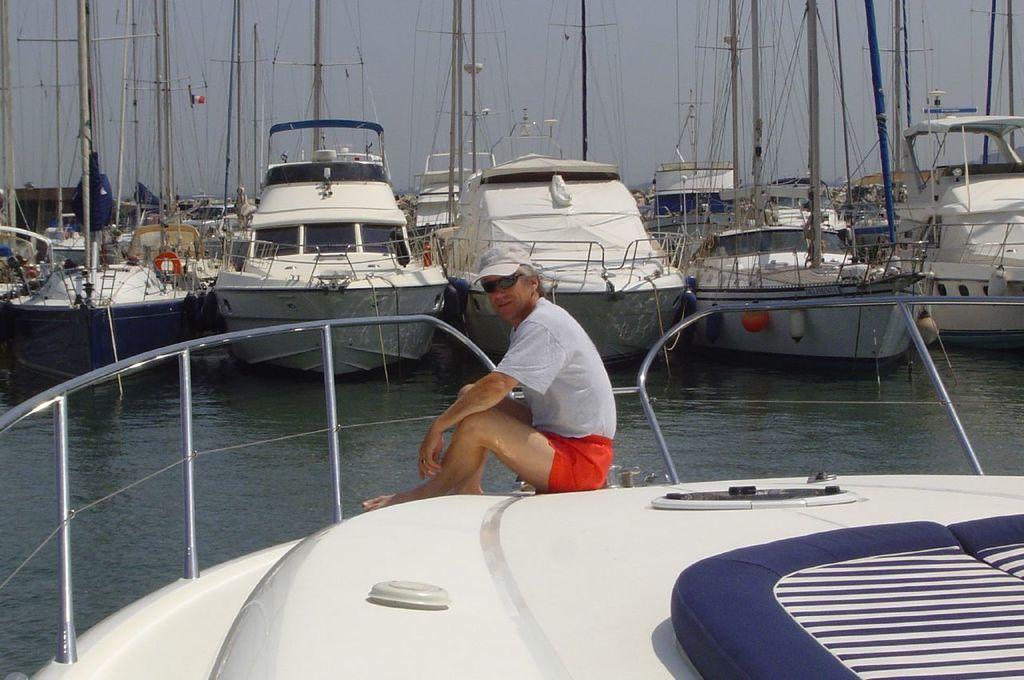In one or two sentences, can you explain what this image depicts? This is an outside view. Here I can see a man wearing white color t-shirt, red color short, white color cap on the head and sitting on the boat and giving pose for the picture. In the background, I can see some more ships on the water. On the top of the image I can see the sky. 